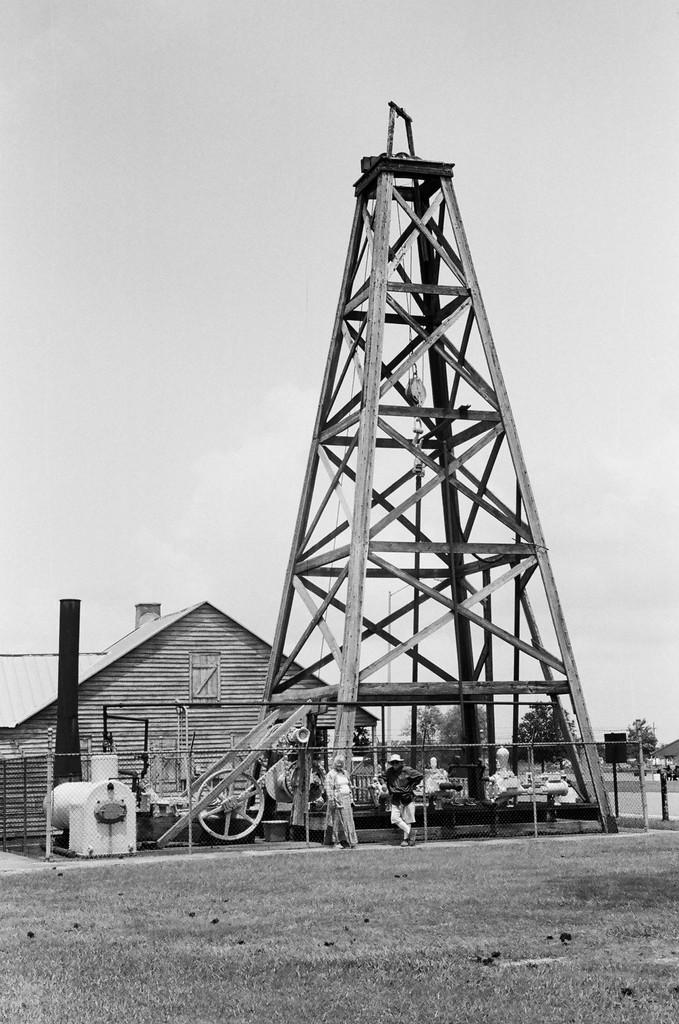Could you give a brief overview of what you see in this image? This is a black and picture. In this image, we can see tower, house, poles, people, wheel, walkway and few objects. In the background, we can see the trees and sky. 